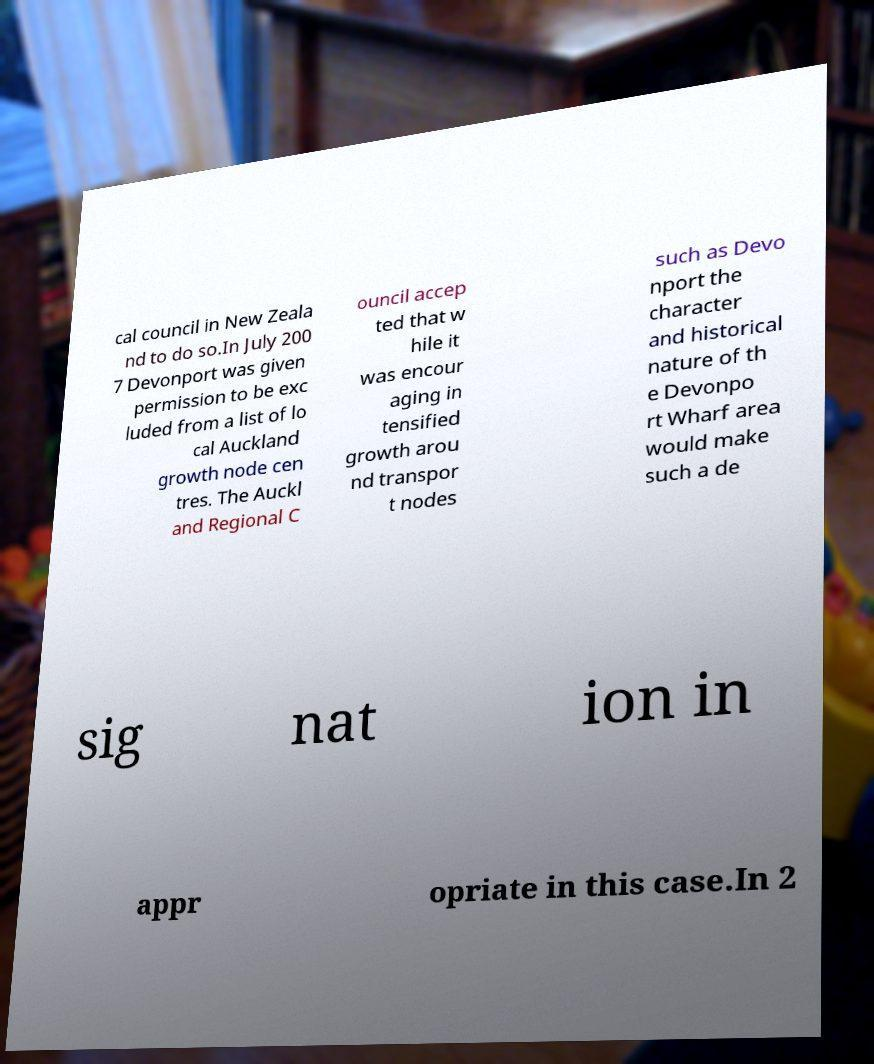Can you accurately transcribe the text from the provided image for me? cal council in New Zeala nd to do so.In July 200 7 Devonport was given permission to be exc luded from a list of lo cal Auckland growth node cen tres. The Auckl and Regional C ouncil accep ted that w hile it was encour aging in tensified growth arou nd transpor t nodes such as Devo nport the character and historical nature of th e Devonpo rt Wharf area would make such a de sig nat ion in appr opriate in this case.In 2 